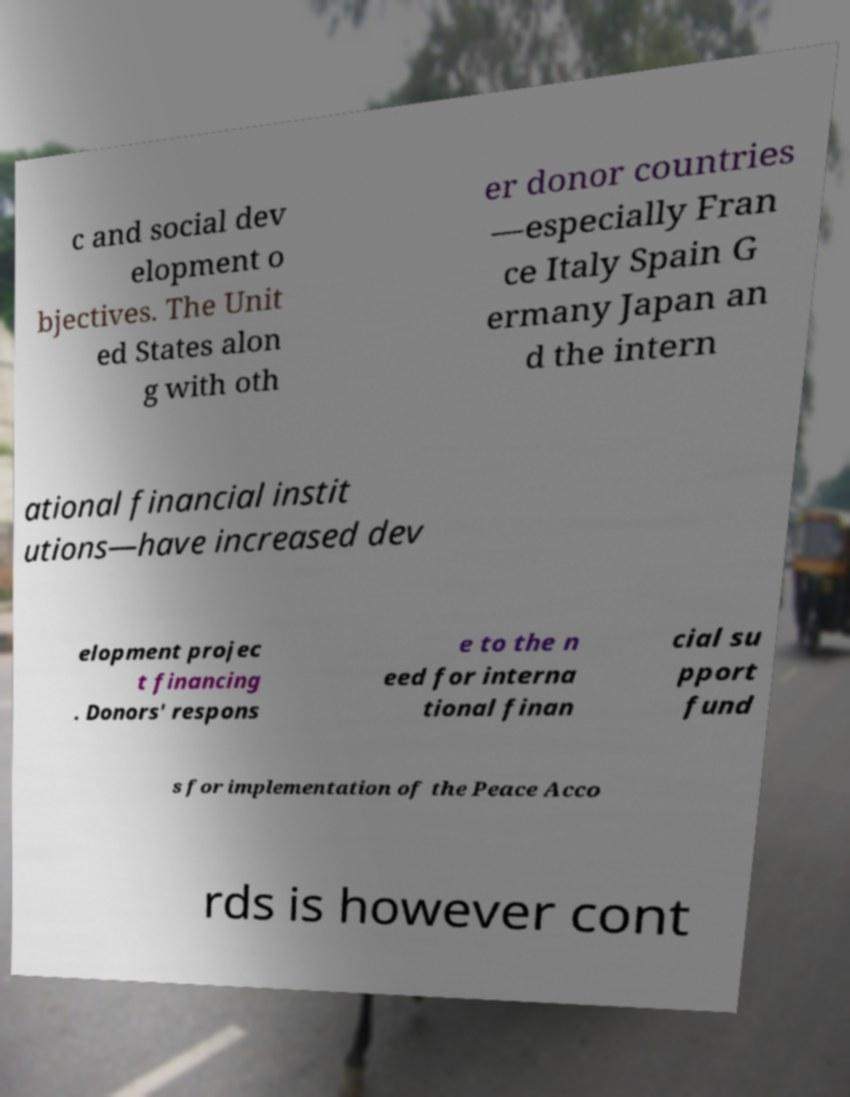Can you accurately transcribe the text from the provided image for me? c and social dev elopment o bjectives. The Unit ed States alon g with oth er donor countries —especially Fran ce Italy Spain G ermany Japan an d the intern ational financial instit utions—have increased dev elopment projec t financing . Donors' respons e to the n eed for interna tional finan cial su pport fund s for implementation of the Peace Acco rds is however cont 